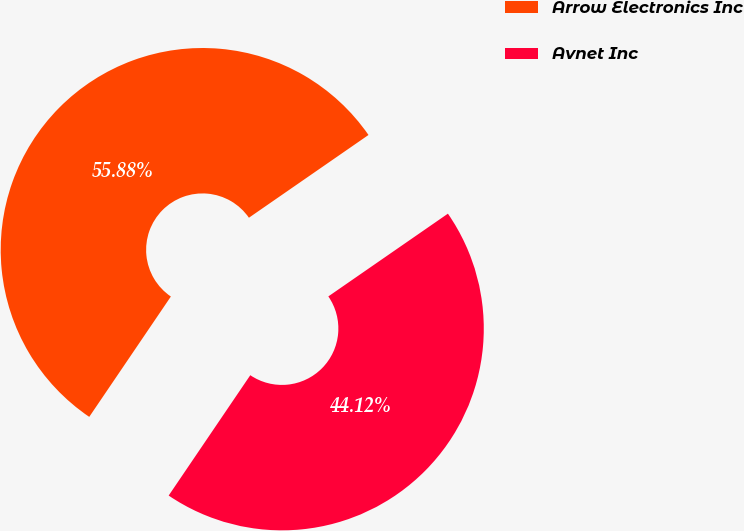<chart> <loc_0><loc_0><loc_500><loc_500><pie_chart><fcel>Arrow Electronics Inc<fcel>Avnet Inc<nl><fcel>55.88%<fcel>44.12%<nl></chart> 